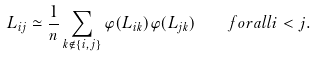<formula> <loc_0><loc_0><loc_500><loc_500>L _ { i j } \simeq \frac { 1 } { n } \sum _ { k \notin \{ i , j \} } \varphi ( L _ { i k } ) \varphi ( L _ { j k } ) \quad f o r a l l i < j .</formula> 